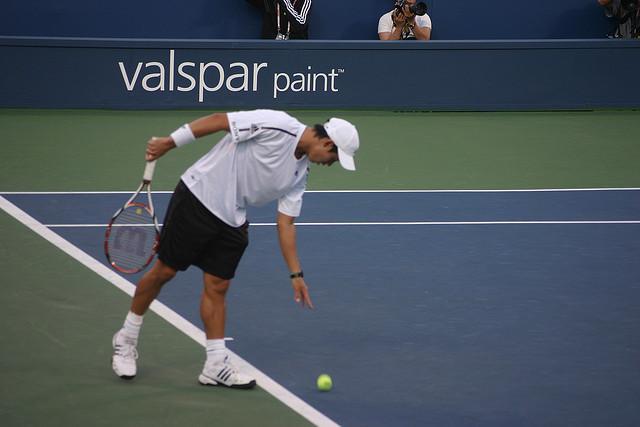How many tennis players are on the tennis court?
Give a very brief answer. 1. How many suitcases have a colorful floral design?
Give a very brief answer. 0. 